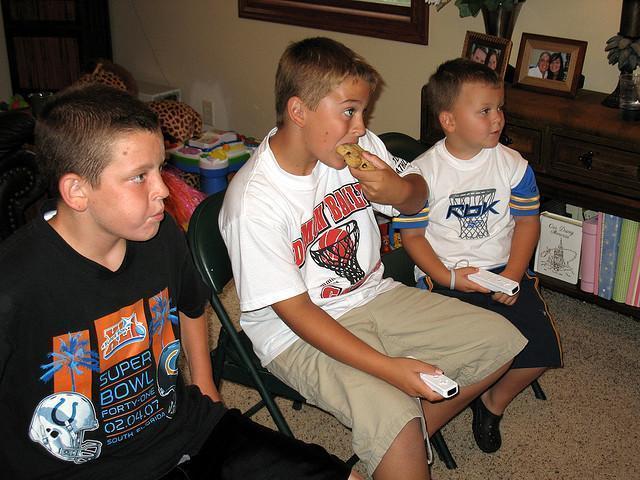How many people are there?
Give a very brief answer. 3. How many chairs are there?
Give a very brief answer. 2. 